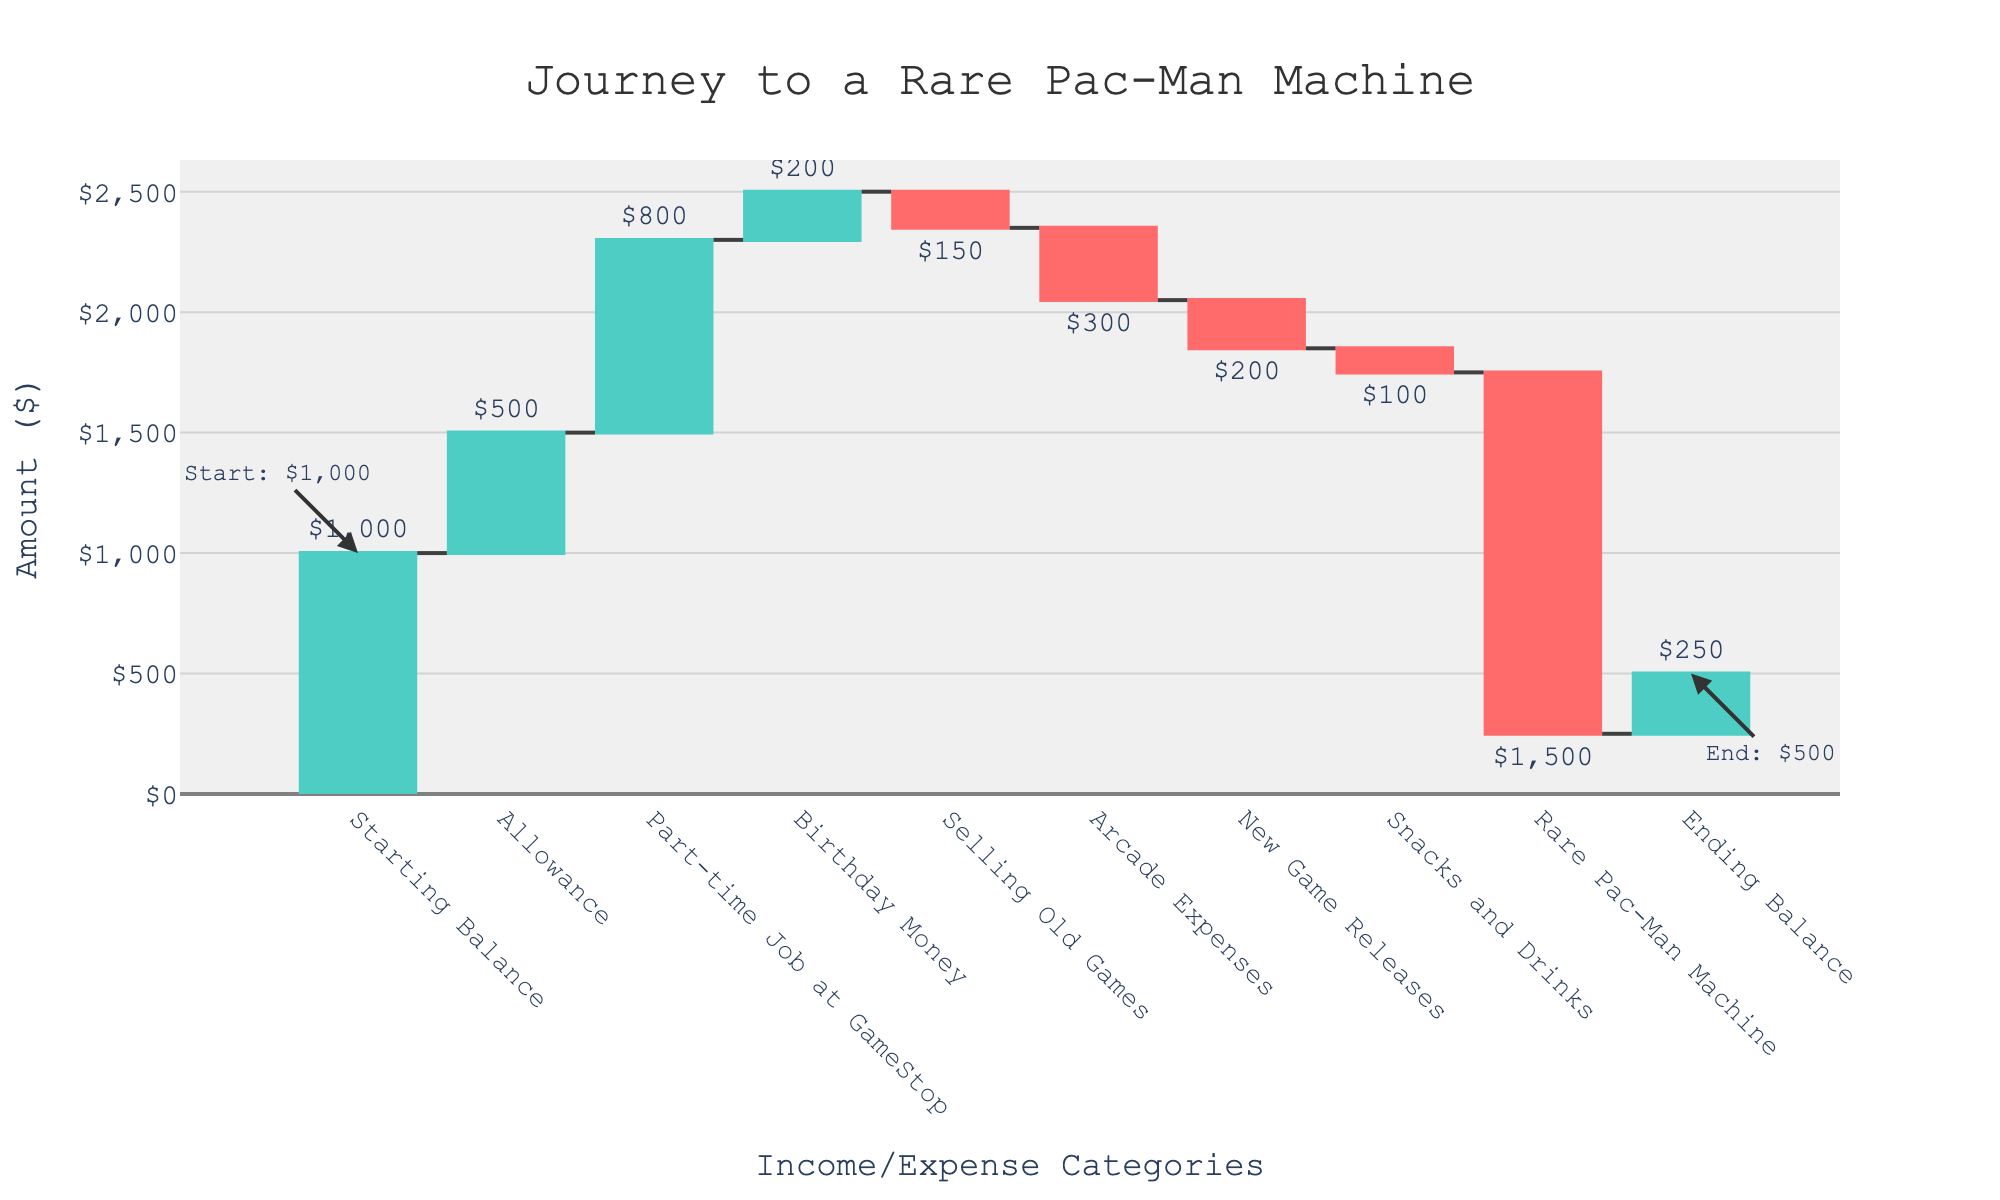How much is the starting balance? The starting balance is represented by the first bar labeled "Starting Balance." It is shown as $1,000.
Answer: $1,000 What is the total income from Allowance and Part-time Job at GameStop? To find the total income from these categories, sum the amounts for "Allowance" ($500) and "Part-time Job at GameStop" ($800). Thus, $500 + $800 = $1,300.
Answer: $1,300 Which category shows the greatest single expense, and what is its amount? By examining the negative values in the chart, the category "Rare Pac-Man Machine" has the largest expense at $1,500.
Answer: Rare Pac-Man Machine, $1,500 How much money was left at the end? The ending balance is depicted as the last bar labeled "Ending Balance," with an amount of $250.
Answer: $250 What is the total amount spent on Arcade Expenses and New Game Releases combined? Sum the expenses for "Arcade Expenses" ($300) and "New Game Releases" ($200), giving a combined total of $300 + $200 = $500.
Answer: $500 What are the two smallest expense categories, and what are their amounts? The smallest expense categories by amount are "Snacks and Drinks" and "Selling Old Games," with amounts of $100 and $150, respectively.
Answer: Snacks and Drinks ($100), Selling Old Games ($150) Which category contributed the most to the savings for the arcade machine, and what was the amount? The category with the highest positive value is "Part-time Job at GameStop," contributing $800.
Answer: Part-time Job at GameStop, $800 How much did the birthday money contribute to the savings? The "Birthday Money" category has a positive value of $200, contributing that amount to the savings.
Answer: $200 What's the net effect of selling old games and buying snacks and drinks on the overall balance? By combining the amounts for "Selling Old Games" (-$150) and "Snacks and Drinks" (-$100), the net effect is -$150 + -$100 = -$250.
Answer: -$250 